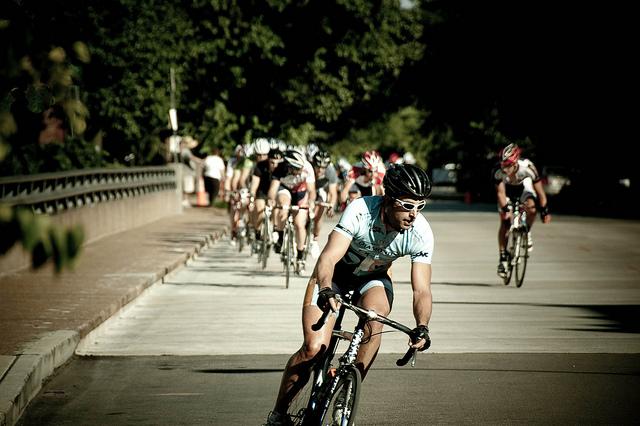Are the bikers racing?
Concise answer only. Yes. How many pedestrians are there?
Quick response, please. 2. What number of people are on bikes?
Write a very short answer. 9. Is someone walking on the sidewalk?
Quick response, please. Yes. 